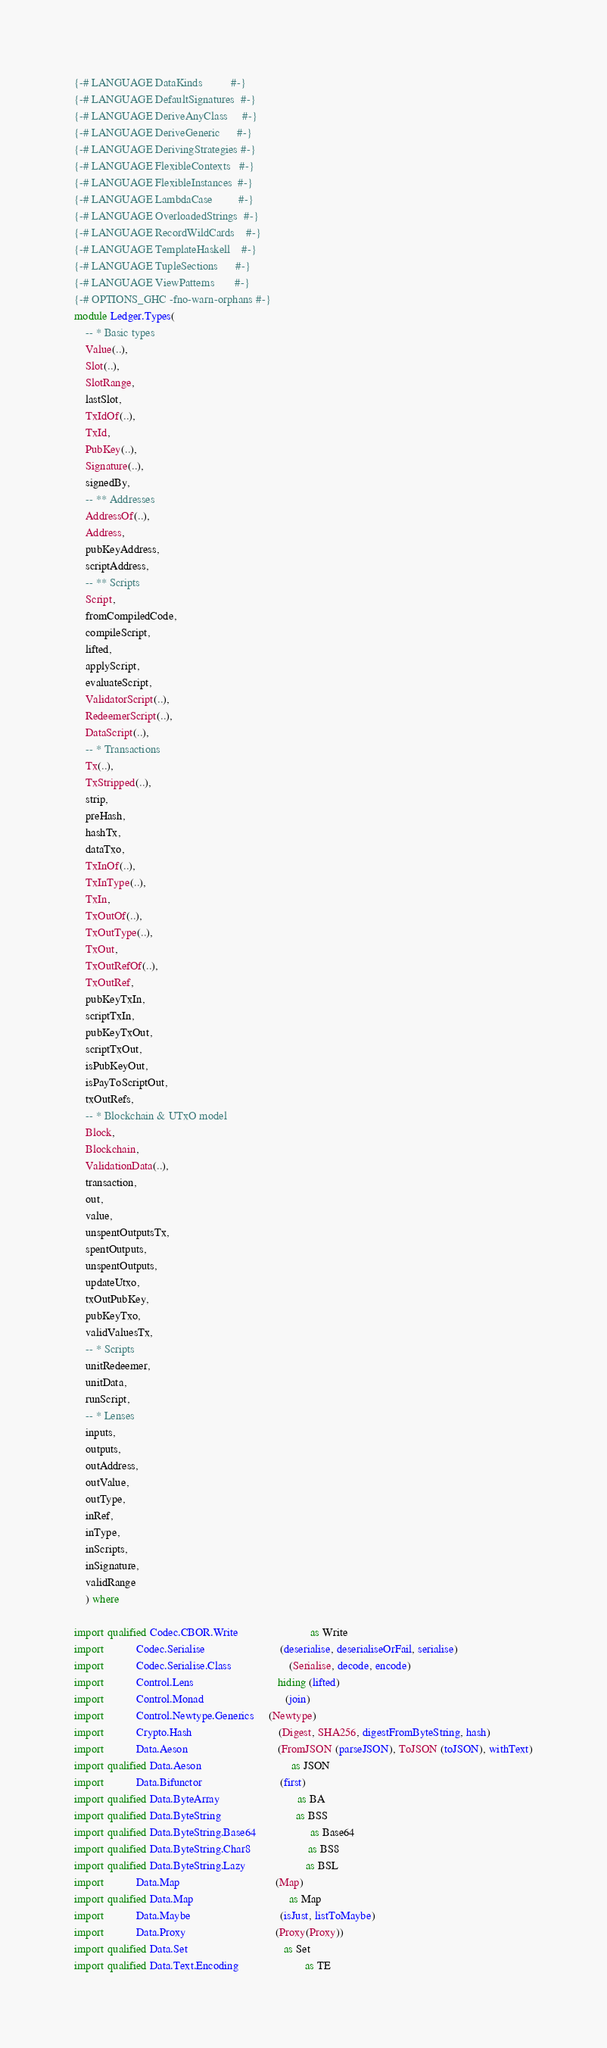<code> <loc_0><loc_0><loc_500><loc_500><_Haskell_>{-# LANGUAGE DataKinds          #-}
{-# LANGUAGE DefaultSignatures  #-}
{-# LANGUAGE DeriveAnyClass     #-}
{-# LANGUAGE DeriveGeneric      #-}
{-# LANGUAGE DerivingStrategies #-}
{-# LANGUAGE FlexibleContexts   #-}
{-# LANGUAGE FlexibleInstances  #-}
{-# LANGUAGE LambdaCase         #-}
{-# LANGUAGE OverloadedStrings  #-}
{-# LANGUAGE RecordWildCards    #-}
{-# LANGUAGE TemplateHaskell    #-}
{-# LANGUAGE TupleSections      #-}
{-# LANGUAGE ViewPatterns       #-}
{-# OPTIONS_GHC -fno-warn-orphans #-}
module Ledger.Types(
    -- * Basic types
    Value(..),
    Slot(..),
    SlotRange,
    lastSlot,
    TxIdOf(..),
    TxId,
    PubKey(..),
    Signature(..),
    signedBy,
    -- ** Addresses
    AddressOf(..),
    Address,
    pubKeyAddress,
    scriptAddress,
    -- ** Scripts
    Script,
    fromCompiledCode,
    compileScript,
    lifted,
    applyScript,
    evaluateScript,
    ValidatorScript(..),
    RedeemerScript(..),
    DataScript(..),
    -- * Transactions
    Tx(..),
    TxStripped(..),
    strip,
    preHash,
    hashTx,
    dataTxo,
    TxInOf(..),
    TxInType(..),
    TxIn,
    TxOutOf(..),
    TxOutType(..),
    TxOut,
    TxOutRefOf(..),
    TxOutRef,
    pubKeyTxIn,
    scriptTxIn,
    pubKeyTxOut,
    scriptTxOut,
    isPubKeyOut,
    isPayToScriptOut,
    txOutRefs,
    -- * Blockchain & UTxO model
    Block,
    Blockchain,
    ValidationData(..),
    transaction,
    out,
    value,
    unspentOutputsTx,
    spentOutputs,
    unspentOutputs,
    updateUtxo,
    txOutPubKey,
    pubKeyTxo,
    validValuesTx,
    -- * Scripts
    unitRedeemer,
    unitData,
    runScript,
    -- * Lenses
    inputs,
    outputs,
    outAddress,
    outValue,
    outType,
    inRef,
    inType,
    inScripts,
    inSignature,
    validRange
    ) where

import qualified Codec.CBOR.Write                         as Write
import           Codec.Serialise                          (deserialise, deserialiseOrFail, serialise)
import           Codec.Serialise.Class                    (Serialise, decode, encode)
import           Control.Lens                             hiding (lifted)
import           Control.Monad                            (join)
import           Control.Newtype.Generics     (Newtype)
import           Crypto.Hash                              (Digest, SHA256, digestFromByteString, hash)
import           Data.Aeson                               (FromJSON (parseJSON), ToJSON (toJSON), withText)
import qualified Data.Aeson                               as JSON
import           Data.Bifunctor                           (first)
import qualified Data.ByteArray                           as BA
import qualified Data.ByteString                          as BSS
import qualified Data.ByteString.Base64                   as Base64
import qualified Data.ByteString.Char8                    as BS8
import qualified Data.ByteString.Lazy                     as BSL
import           Data.Map                                 (Map)
import qualified Data.Map                                 as Map
import           Data.Maybe                               (isJust, listToMaybe)
import           Data.Proxy                               (Proxy(Proxy))
import qualified Data.Set                                 as Set
import qualified Data.Text.Encoding                       as TE</code> 